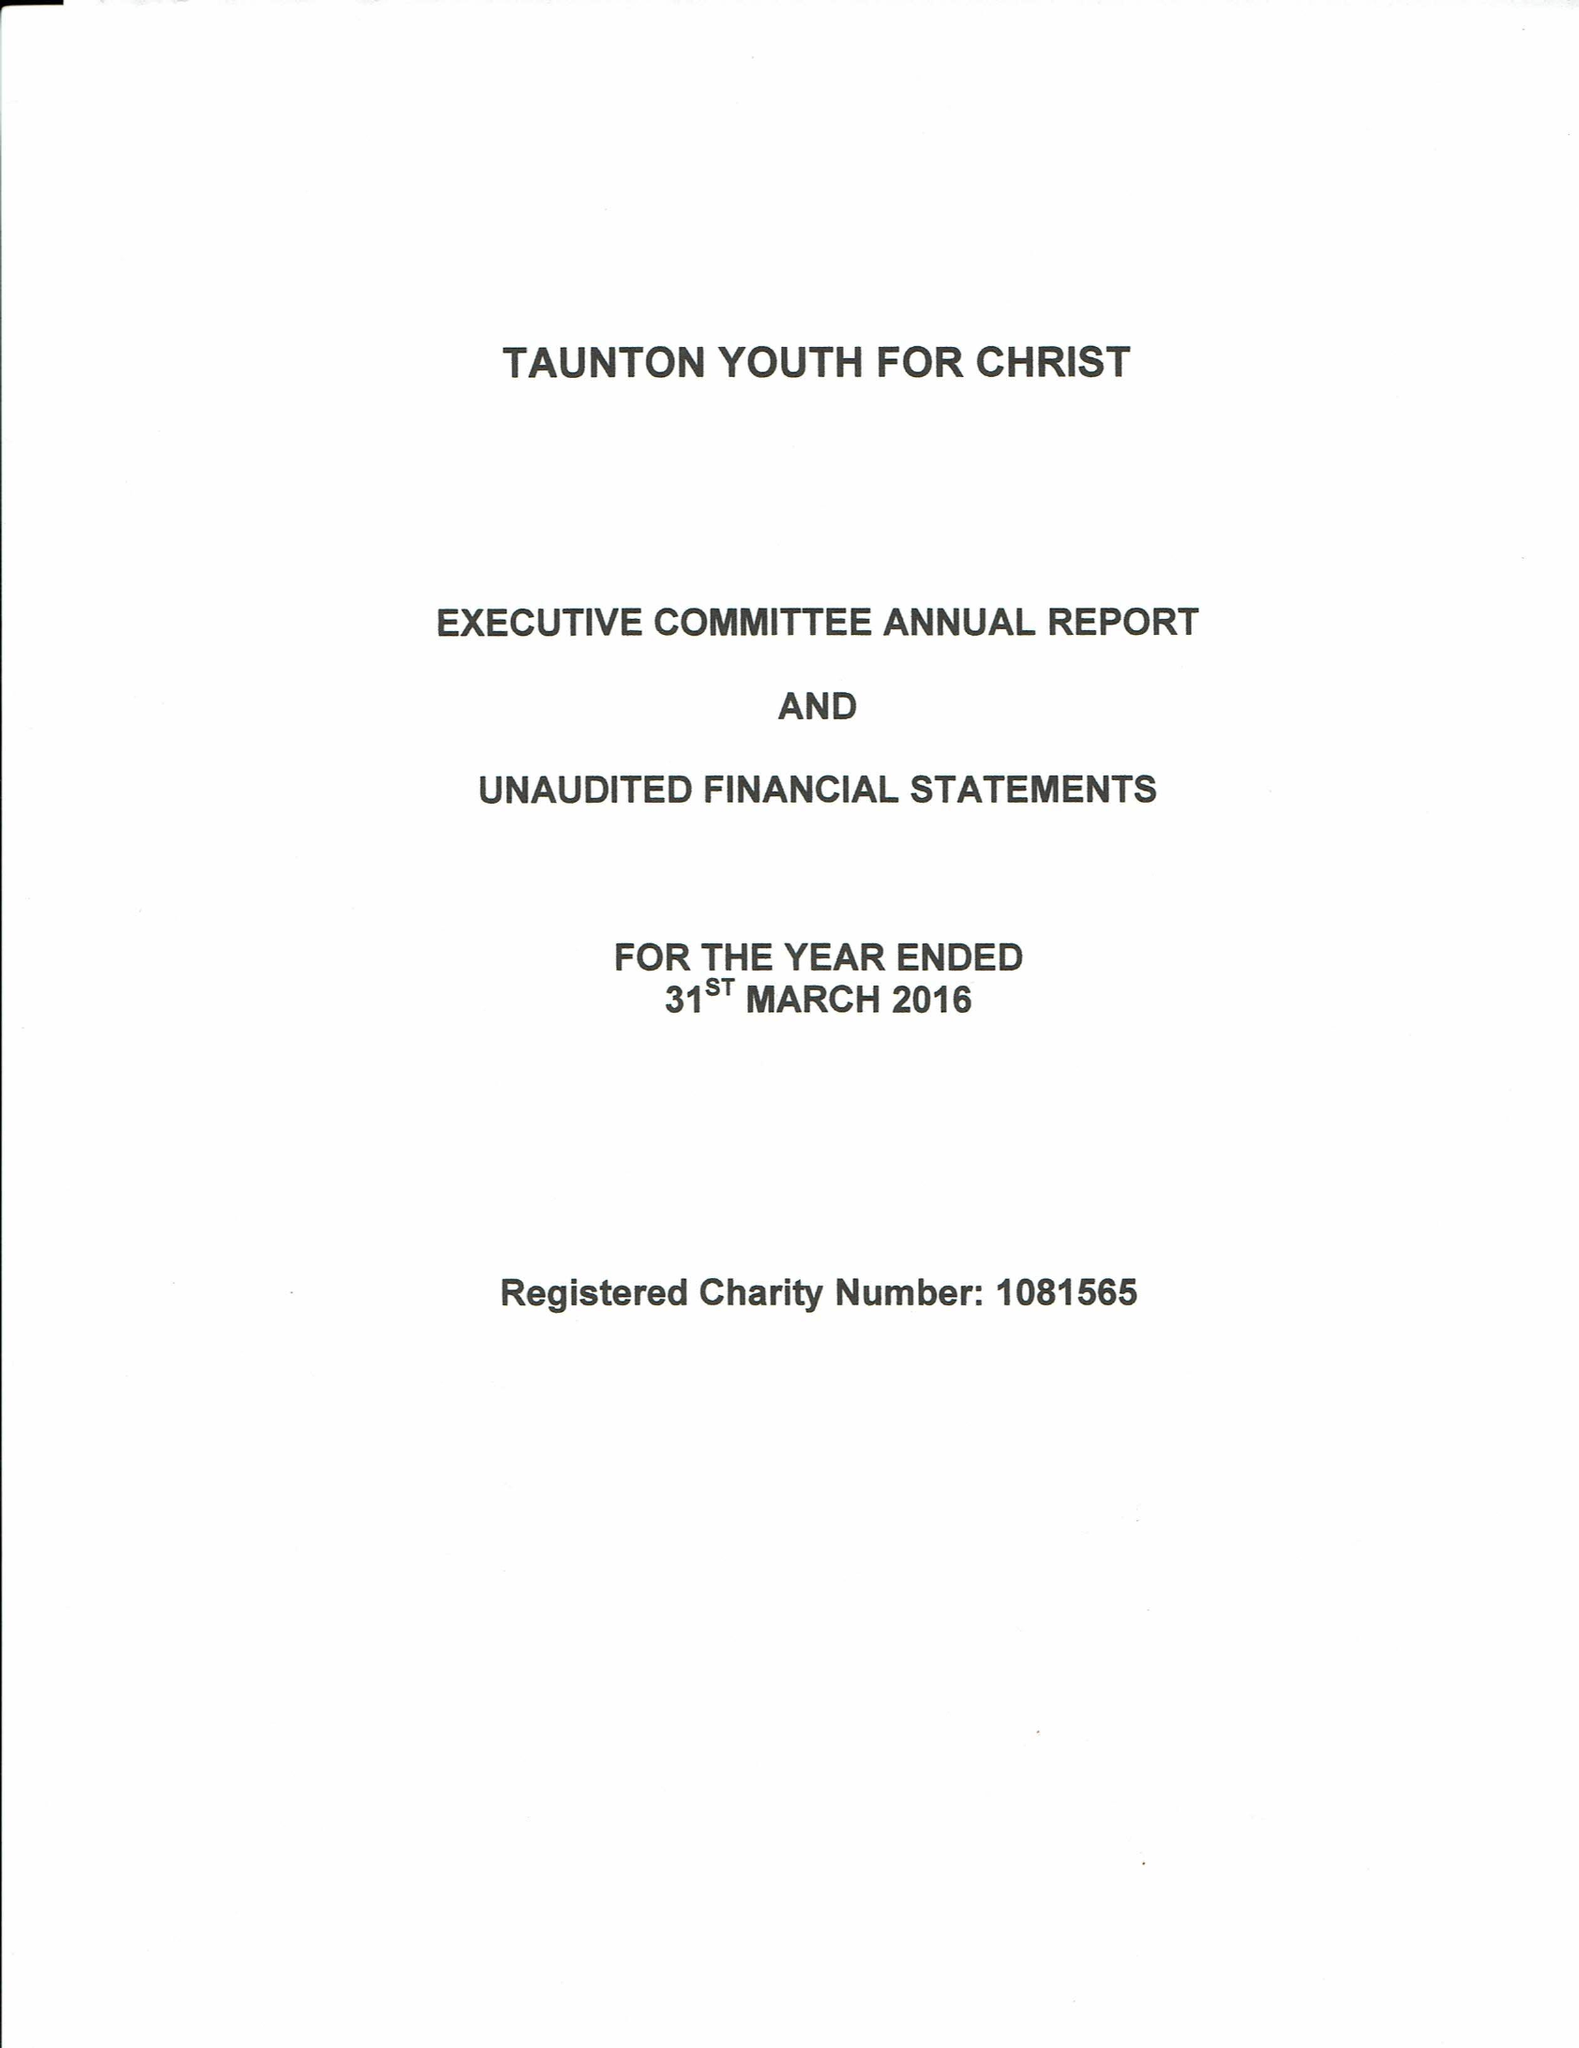What is the value for the spending_annually_in_british_pounds?
Answer the question using a single word or phrase. 29376.00 